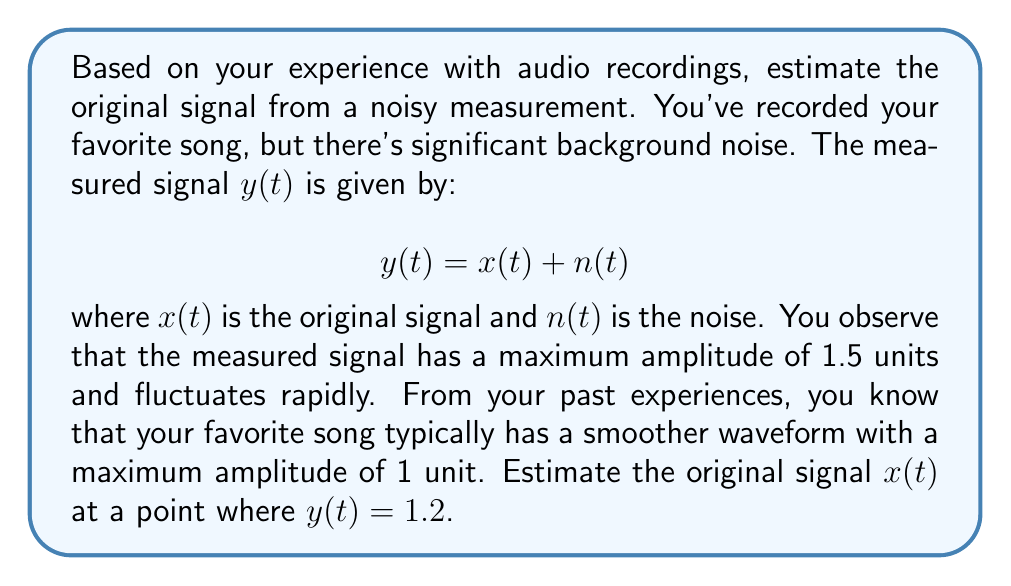Could you help me with this problem? To estimate the original signal from the noisy measurement using personal experience, we can follow these steps:

1. Recognize the given information:
   - The measured signal: $y(t) = x(t) + n(t)$
   - Maximum amplitude of measured signal: 1.5 units
   - Maximum amplitude of original signal (based on experience): 1 unit
   - Measured signal at the point of interest: $y(t) = 1.2$

2. Estimate the noise level:
   The difference between the maximum amplitudes gives us an idea of the noise level.
   Estimated maximum noise = 1.5 - 1 = 0.5 units

3. Consider the point where $y(t) = 1.2$:
   This value is above the expected maximum of the original signal (1 unit), suggesting the presence of noise.

4. Estimate the original signal:
   Given that the original signal typically has a maximum amplitude of 1 unit, and considering the noise level, we can estimate that the original signal at this point is likely closer to 1 than to 1.2.

5. Make an educated guess:
   A reasonable estimate for $x(t)$ could be around 0.9 to 1 unit at this point, allowing for some noise contribution to reach the measured 1.2 units.

6. Final estimate:
   Let's settle on $x(t) \approx 0.95$ as our estimate for the original signal at this point.

This approach relies heavily on personal experience with the song's typical waveform and intuition about noise levels, which aligns with the given persona's preference for decision-making based on personal opinions and experiences.
Answer: $x(t) \approx 0.95$ 